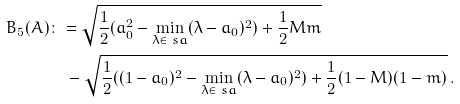<formula> <loc_0><loc_0><loc_500><loc_500>\ B _ { 5 } ( A ) & \colon = \sqrt { \frac { 1 } { 2 } ( a _ { 0 } ^ { 2 } - \min _ { \lambda \in \ s a } ( \lambda - a _ { 0 } ) ^ { 2 } ) + \frac { 1 } { 2 } M m } \\ & \quad - \sqrt { \frac { 1 } { 2 } ( ( 1 - a _ { 0 } ) ^ { 2 } - \min _ { \lambda \in \ s a } ( \lambda - a _ { 0 } ) ^ { 2 } ) + \frac { 1 } { 2 } ( 1 - M ) ( 1 - m ) } \, .</formula> 